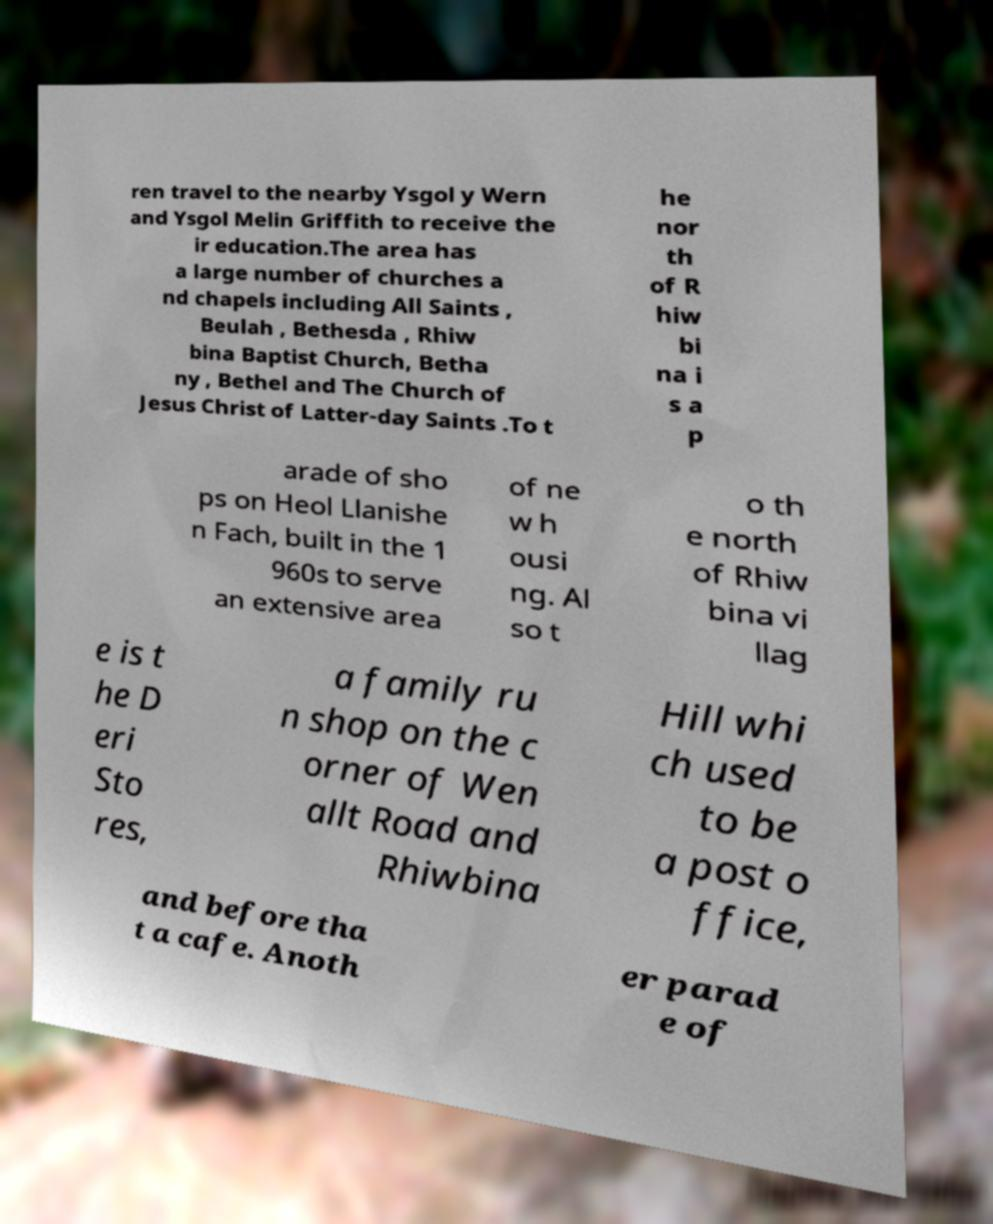Could you extract and type out the text from this image? ren travel to the nearby Ysgol y Wern and Ysgol Melin Griffith to receive the ir education.The area has a large number of churches a nd chapels including All Saints , Beulah , Bethesda , Rhiw bina Baptist Church, Betha ny , Bethel and The Church of Jesus Christ of Latter-day Saints .To t he nor th of R hiw bi na i s a p arade of sho ps on Heol Llanishe n Fach, built in the 1 960s to serve an extensive area of ne w h ousi ng. Al so t o th e north of Rhiw bina vi llag e is t he D eri Sto res, a family ru n shop on the c orner of Wen allt Road and Rhiwbina Hill whi ch used to be a post o ffice, and before tha t a cafe. Anoth er parad e of 